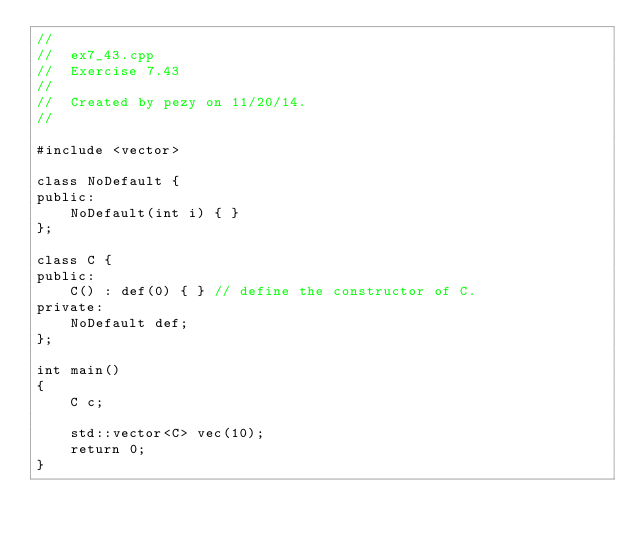Convert code to text. <code><loc_0><loc_0><loc_500><loc_500><_C++_>//
//  ex7_43.cpp
//  Exercise 7.43
//
//  Created by pezy on 11/20/14.
//

#include <vector> 

class NoDefault {
public:
    NoDefault(int i) { }
};

class C {
public:
    C() : def(0) { } // define the constructor of C.
private:
    NoDefault def;
};

int main()
{
    C c;
    
    std::vector<C> vec(10); 
    return 0;
}
</code> 